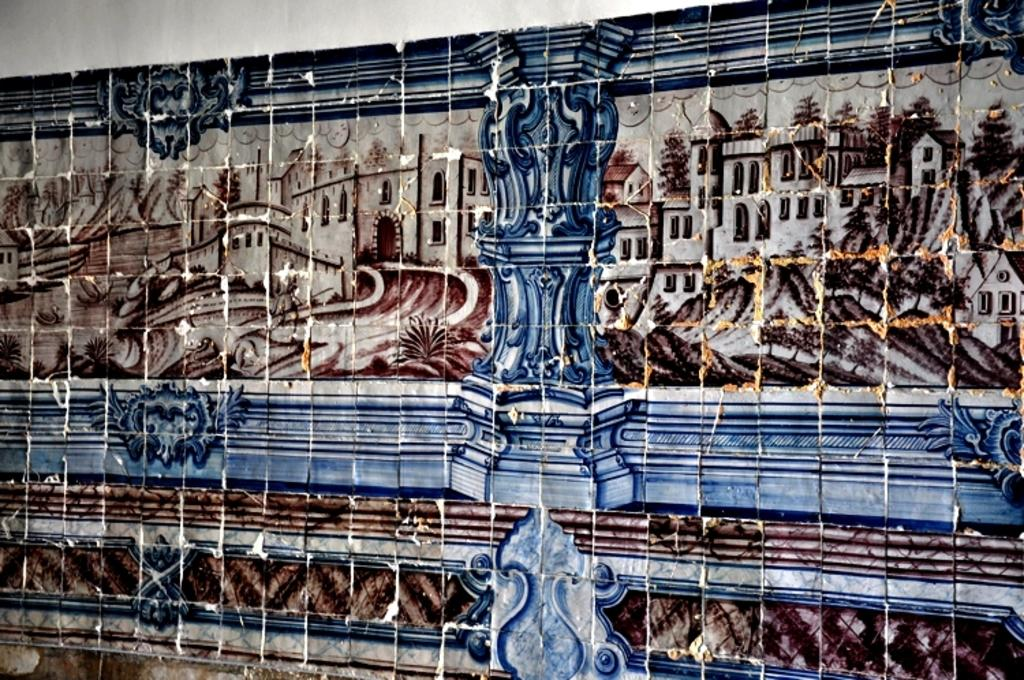What is present on the wall in the image? There is a painting on the wall in the image. Can you describe the painting? Unfortunately, the facts provided do not give any details about the painting. What is the color of the wall in the image? The facts provided do not mention the color of the wall. What knowledge can be gained from the thunder in the image? There is no thunder present in the image, so no knowledge can be gained from it. 